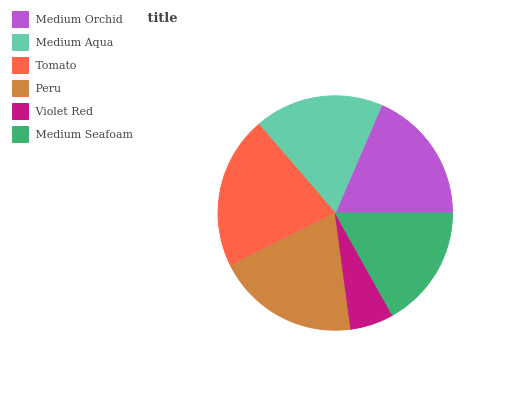Is Violet Red the minimum?
Answer yes or no. Yes. Is Tomato the maximum?
Answer yes or no. Yes. Is Medium Aqua the minimum?
Answer yes or no. No. Is Medium Aqua the maximum?
Answer yes or no. No. Is Medium Orchid greater than Medium Aqua?
Answer yes or no. Yes. Is Medium Aqua less than Medium Orchid?
Answer yes or no. Yes. Is Medium Aqua greater than Medium Orchid?
Answer yes or no. No. Is Medium Orchid less than Medium Aqua?
Answer yes or no. No. Is Medium Orchid the high median?
Answer yes or no. Yes. Is Medium Aqua the low median?
Answer yes or no. Yes. Is Violet Red the high median?
Answer yes or no. No. Is Medium Orchid the low median?
Answer yes or no. No. 